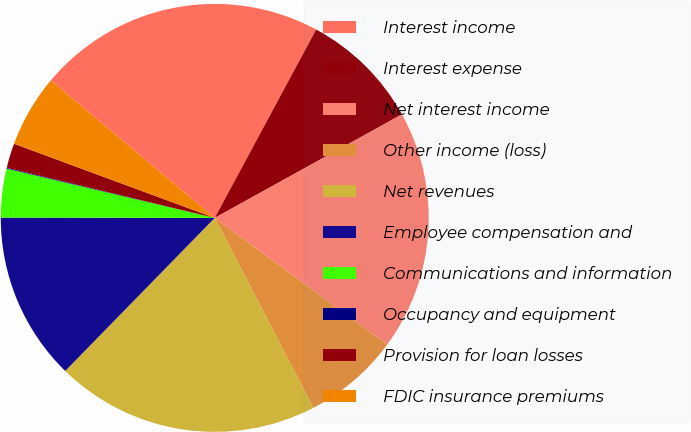Convert chart. <chart><loc_0><loc_0><loc_500><loc_500><pie_chart><fcel>Interest income<fcel>Interest expense<fcel>Net interest income<fcel>Other income (loss)<fcel>Net revenues<fcel>Employee compensation and<fcel>Communications and information<fcel>Occupancy and equipment<fcel>Provision for loan losses<fcel>FDIC insurance premiums<nl><fcel>21.75%<fcel>9.1%<fcel>18.13%<fcel>7.29%<fcel>19.94%<fcel>12.71%<fcel>3.68%<fcel>0.06%<fcel>1.87%<fcel>5.48%<nl></chart> 